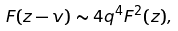Convert formula to latex. <formula><loc_0><loc_0><loc_500><loc_500>F ( z - v ) \sim 4 q ^ { 4 } F ^ { 2 } ( z ) ,</formula> 